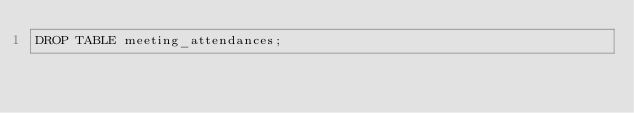Convert code to text. <code><loc_0><loc_0><loc_500><loc_500><_SQL_>DROP TABLE meeting_attendances;</code> 